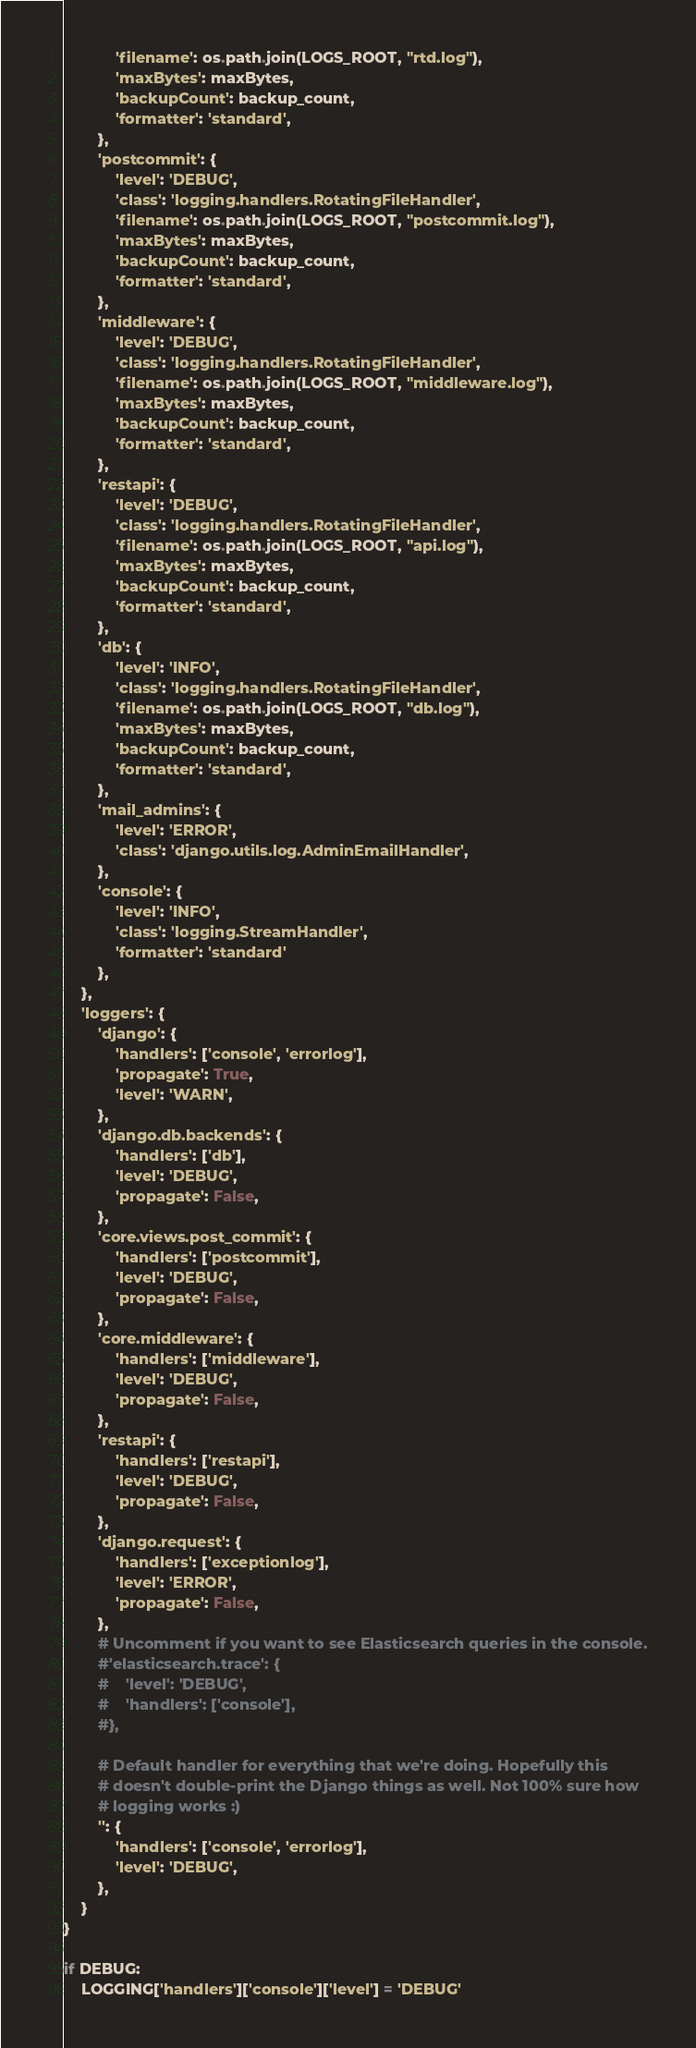<code> <loc_0><loc_0><loc_500><loc_500><_Python_>            'filename': os.path.join(LOGS_ROOT, "rtd.log"),
            'maxBytes': maxBytes,
            'backupCount': backup_count,
            'formatter': 'standard',
        },
        'postcommit': {
            'level': 'DEBUG',
            'class': 'logging.handlers.RotatingFileHandler',
            'filename': os.path.join(LOGS_ROOT, "postcommit.log"),
            'maxBytes': maxBytes,
            'backupCount': backup_count,
            'formatter': 'standard',
        },
        'middleware': {
            'level': 'DEBUG',
            'class': 'logging.handlers.RotatingFileHandler',
            'filename': os.path.join(LOGS_ROOT, "middleware.log"),
            'maxBytes': maxBytes,
            'backupCount': backup_count,
            'formatter': 'standard',
        },
        'restapi': {
            'level': 'DEBUG',
            'class': 'logging.handlers.RotatingFileHandler',
            'filename': os.path.join(LOGS_ROOT, "api.log"),
            'maxBytes': maxBytes,
            'backupCount': backup_count,
            'formatter': 'standard',
        },
        'db': {
            'level': 'INFO',
            'class': 'logging.handlers.RotatingFileHandler',
            'filename': os.path.join(LOGS_ROOT, "db.log"),
            'maxBytes': maxBytes,
            'backupCount': backup_count,
            'formatter': 'standard',
        },
        'mail_admins': {
            'level': 'ERROR',
            'class': 'django.utils.log.AdminEmailHandler',
        },
        'console': {
            'level': 'INFO',
            'class': 'logging.StreamHandler',
            'formatter': 'standard'
        },
    },
    'loggers': {
        'django': {
            'handlers': ['console', 'errorlog'],
            'propagate': True,
            'level': 'WARN',
        },
        'django.db.backends': {
            'handlers': ['db'],
            'level': 'DEBUG',
            'propagate': False,
        },
        'core.views.post_commit': {
            'handlers': ['postcommit'],
            'level': 'DEBUG',
            'propagate': False,
        },
        'core.middleware': {
            'handlers': ['middleware'],
            'level': 'DEBUG',
            'propagate': False,
        },
        'restapi': {
            'handlers': ['restapi'],
            'level': 'DEBUG',
            'propagate': False,
        },
        'django.request': {
            'handlers': ['exceptionlog'],
            'level': 'ERROR',
            'propagate': False,
        },
        # Uncomment if you want to see Elasticsearch queries in the console.
        #'elasticsearch.trace': {
        #    'level': 'DEBUG',
        #    'handlers': ['console'],
        #},

        # Default handler for everything that we're doing. Hopefully this
        # doesn't double-print the Django things as well. Not 100% sure how
        # logging works :)
        '': {
            'handlers': ['console', 'errorlog'],
            'level': 'DEBUG',
        },
    }
}

if DEBUG:
    LOGGING['handlers']['console']['level'] = 'DEBUG'
</code> 